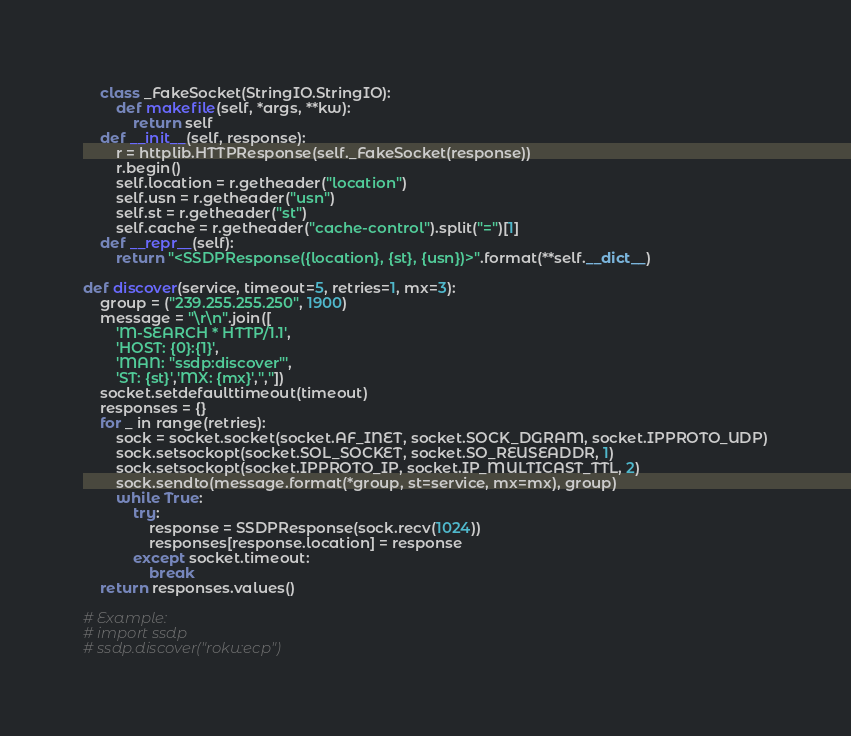Convert code to text. <code><loc_0><loc_0><loc_500><loc_500><_Python_>    class _FakeSocket(StringIO.StringIO):
        def makefile(self, *args, **kw):
            return self
    def __init__(self, response):
        r = httplib.HTTPResponse(self._FakeSocket(response))
        r.begin()
        self.location = r.getheader("location")
        self.usn = r.getheader("usn")
        self.st = r.getheader("st")
        self.cache = r.getheader("cache-control").split("=")[1]
    def __repr__(self):
        return "<SSDPResponse({location}, {st}, {usn})>".format(**self.__dict__)

def discover(service, timeout=5, retries=1, mx=3):
    group = ("239.255.255.250", 1900)
    message = "\r\n".join([
        'M-SEARCH * HTTP/1.1',
        'HOST: {0}:{1}',
        'MAN: "ssdp:discover"',
        'ST: {st}','MX: {mx}','',''])
    socket.setdefaulttimeout(timeout)
    responses = {}
    for _ in range(retries):
        sock = socket.socket(socket.AF_INET, socket.SOCK_DGRAM, socket.IPPROTO_UDP)
        sock.setsockopt(socket.SOL_SOCKET, socket.SO_REUSEADDR, 1)
        sock.setsockopt(socket.IPPROTO_IP, socket.IP_MULTICAST_TTL, 2)
        sock.sendto(message.format(*group, st=service, mx=mx), group)
        while True:
            try:
                response = SSDPResponse(sock.recv(1024))
                responses[response.location] = response
            except socket.timeout:
                break
    return responses.values()

# Example:
# import ssdp
# ssdp.discover("roku:ecp")</code> 